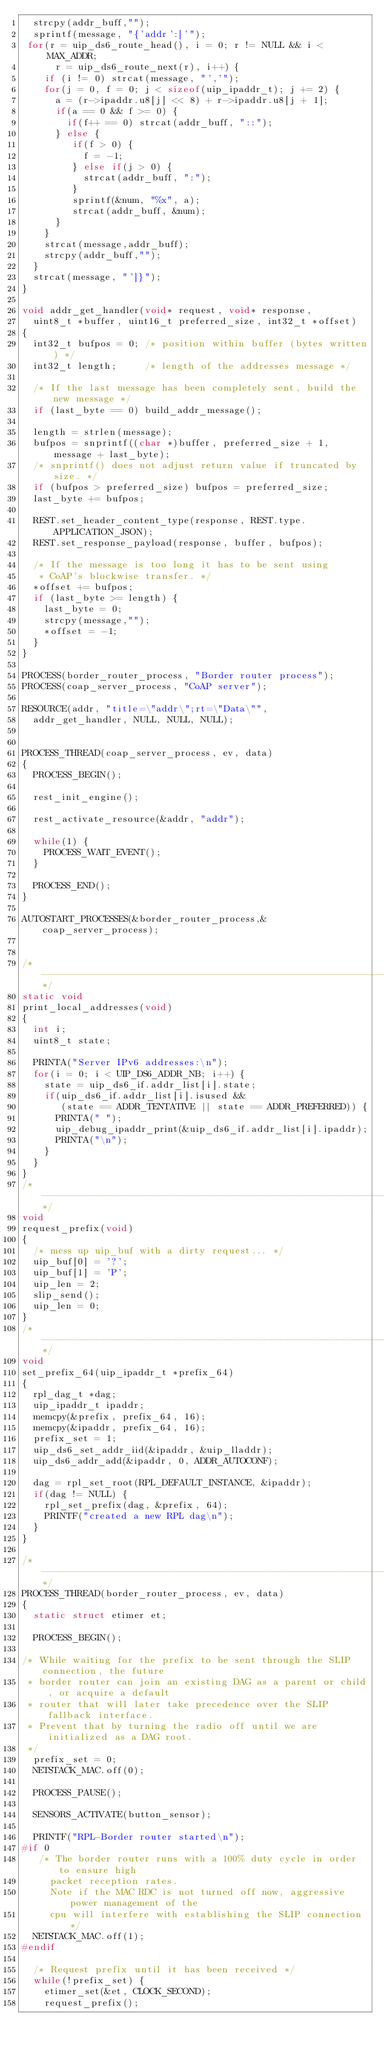Convert code to text. <code><loc_0><loc_0><loc_500><loc_500><_C_>  strcpy(addr_buff,"");
  sprintf(message, "{'addr':['");
 for(r = uip_ds6_route_head(), i = 0; r != NULL && i < MAX_ADDR;
      r = uip_ds6_route_next(r), i++) {
    if (i != 0) strcat(message, "','");
    for(j = 0, f = 0; j < sizeof(uip_ipaddr_t); j += 2) {
      a = (r->ipaddr.u8[j] << 8) + r->ipaddr.u8[j + 1];
      if(a == 0 && f >= 0) {
        if(f++ == 0) strcat(addr_buff, "::");
      } else {
         if(f > 0) {
           f = -1;
         } else if(j > 0) {
           strcat(addr_buff, ":");
         }
         sprintf(&num, "%x", a);
         strcat(addr_buff, &num);
      }
    }
    strcat(message,addr_buff);
    strcpy(addr_buff,"");
  }
  strcat(message, "']}");
}

void addr_get_handler(void* request, void* response, 
  uint8_t *buffer, uint16_t preferred_size, int32_t *offset)
{
  int32_t bufpos = 0; /* position within buffer (bytes written) */
  int32_t length;     /* length of the addresses message */     
  
  /* If the last message has been completely sent, build the new message */
  if (last_byte == 0) build_addr_message();
  
  length = strlen(message);
  bufpos = snprintf((char *)buffer, preferred_size + 1, message + last_byte);
  /* snprintf() does not adjust return value if truncated by size. */
  if (bufpos > preferred_size) bufpos = preferred_size;
  last_byte += bufpos;
  
  REST.set_header_content_type(response, REST.type.APPLICATION_JSON);
  REST.set_response_payload(response, buffer, bufpos);
  
  /* If the message is too long it has to be sent using
   * CoAP's blockwise transfer. */
  *offset += bufpos;
  if (last_byte >= length) {
    last_byte = 0;
    strcpy(message,"");
    *offset = -1;
  }
}

PROCESS(border_router_process, "Border router process");
PROCESS(coap_server_process, "CoAP server");

RESOURCE(addr, "title=\"addr\";rt=\"Data\"", 
  addr_get_handler, NULL, NULL, NULL);


PROCESS_THREAD(coap_server_process, ev, data)
{
  PROCESS_BEGIN();

  rest_init_engine();
  
  rest_activate_resource(&addr, "addr");

  while(1) {
    PROCESS_WAIT_EVENT();
  }

  PROCESS_END();
}

AUTOSTART_PROCESSES(&border_router_process,&coap_server_process);


/*---------------------------------------------------------------------------*/
static void
print_local_addresses(void)
{
  int i;
  uint8_t state;

  PRINTA("Server IPv6 addresses:\n");
  for(i = 0; i < UIP_DS6_ADDR_NB; i++) {
    state = uip_ds6_if.addr_list[i].state;
    if(uip_ds6_if.addr_list[i].isused &&
       (state == ADDR_TENTATIVE || state == ADDR_PREFERRED)) {
      PRINTA(" ");
      uip_debug_ipaddr_print(&uip_ds6_if.addr_list[i].ipaddr);
      PRINTA("\n");
    }
  }
}
/*---------------------------------------------------------------------------*/
void
request_prefix(void)
{
  /* mess up uip_buf with a dirty request... */
  uip_buf[0] = '?';
  uip_buf[1] = 'P';
  uip_len = 2;
  slip_send();
  uip_len = 0;
}
/*---------------------------------------------------------------------------*/
void
set_prefix_64(uip_ipaddr_t *prefix_64)
{
  rpl_dag_t *dag;
  uip_ipaddr_t ipaddr;
  memcpy(&prefix, prefix_64, 16);
  memcpy(&ipaddr, prefix_64, 16);
  prefix_set = 1;
  uip_ds6_set_addr_iid(&ipaddr, &uip_lladdr);
  uip_ds6_addr_add(&ipaddr, 0, ADDR_AUTOCONF);

  dag = rpl_set_root(RPL_DEFAULT_INSTANCE, &ipaddr);
  if(dag != NULL) {
    rpl_set_prefix(dag, &prefix, 64);
    PRINTF("created a new RPL dag\n");
  }
}

/*---------------------------------------------------------------------------*/
PROCESS_THREAD(border_router_process, ev, data)
{
  static struct etimer et;

  PROCESS_BEGIN();

/* While waiting for the prefix to be sent through the SLIP connection, the future
 * border router can join an existing DAG as a parent or child, or acquire a default
 * router that will later take precedence over the SLIP fallback interface.
 * Prevent that by turning the radio off until we are initialized as a DAG root.
 */
  prefix_set = 0;
  NETSTACK_MAC.off(0);

  PROCESS_PAUSE();

  SENSORS_ACTIVATE(button_sensor);

  PRINTF("RPL-Border router started\n");
#if 0
   /* The border router runs with a 100% duty cycle in order to ensure high
     packet reception rates.
     Note if the MAC RDC is not turned off now, aggressive power management of the
     cpu will interfere with establishing the SLIP connection */
  NETSTACK_MAC.off(1);
#endif

  /* Request prefix until it has been received */
  while(!prefix_set) {
    etimer_set(&et, CLOCK_SECOND);
    request_prefix();</code> 